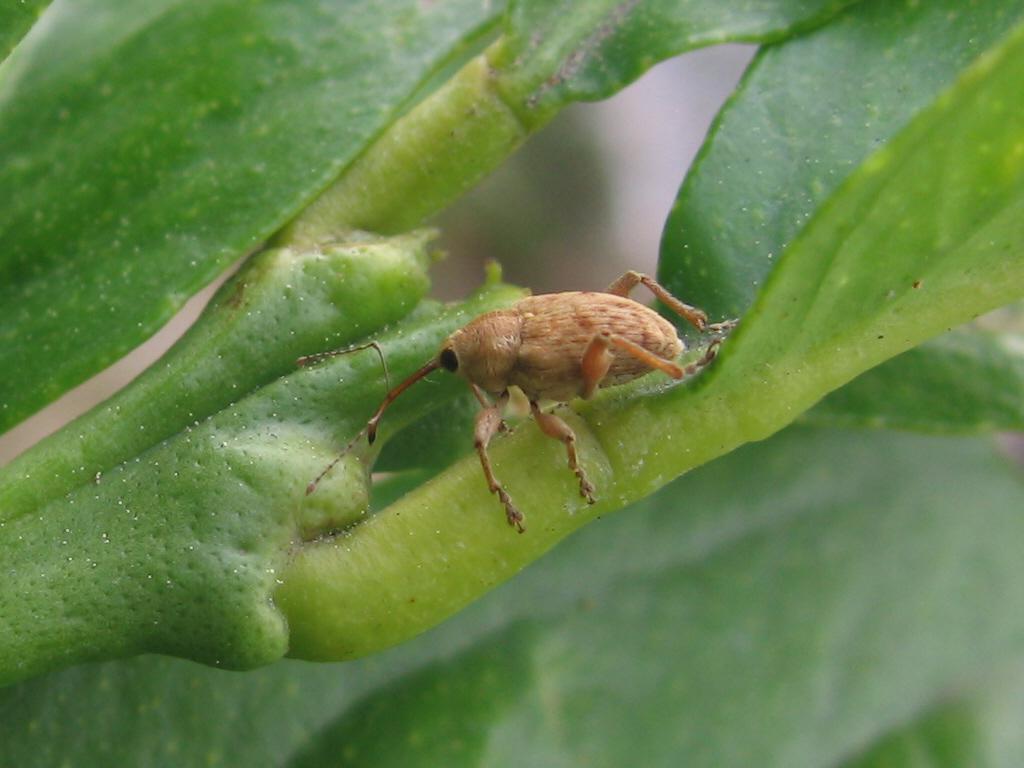In one or two sentences, can you explain what this image depicts? In this picture I can see there is a bug, there is a stem of a plant and the backdrop is blurred. 